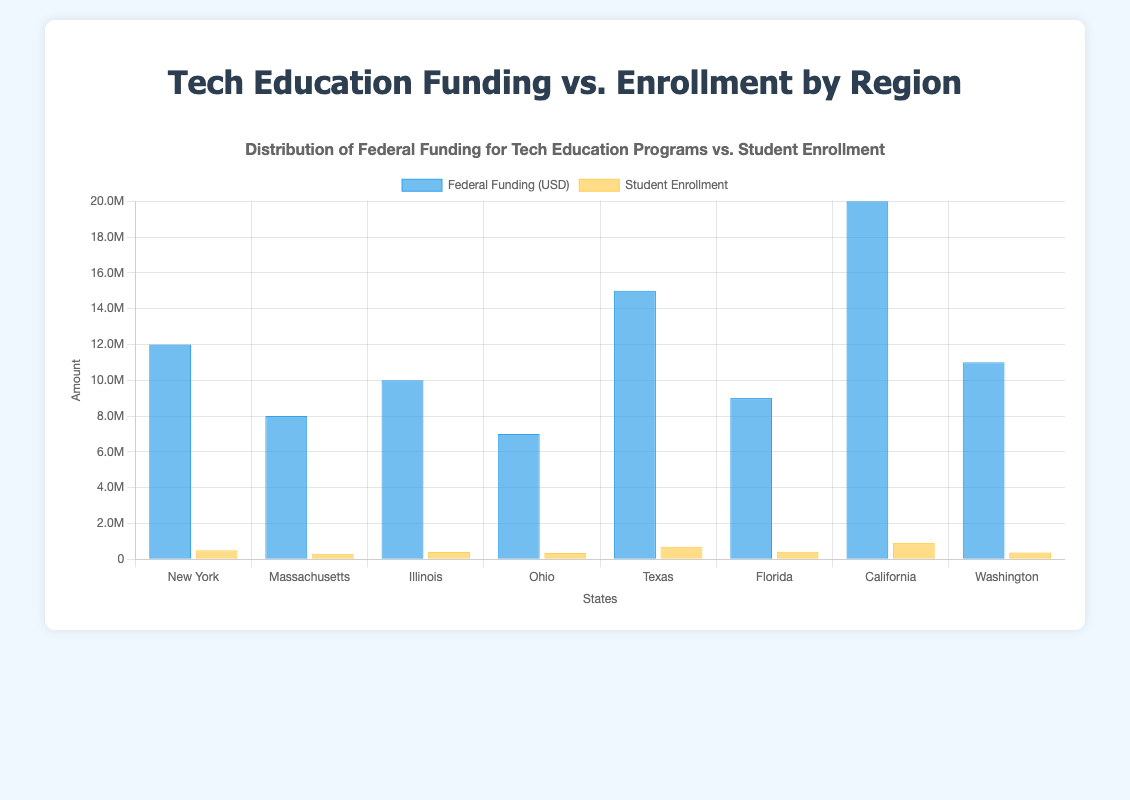Which state in the South region receives the most federal funding for tech education? Texas receives $15,000,000, which is more than Florida's $9,000,000.
Answer: Texas Which state has the highest student enrollment in tech education programs? California has the highest student enrollment with 900,000 students.
Answer: California How does the federal funding for tech education in New York compare to that in Massachusetts? New York receives $12,000,000 while Massachusetts receives $8,000,000. New York gets $4,000,000 more.
Answer: New York receives $4,000,000 more What's the average federal funding for tech education programs in the Northeast region? The Northeast has New York ($12,000,000) and Massachusetts ($8,000,000). Average funding = ($12,000,000 + $8,000,000) / 2 = $10,000,000.
Answer: $10,000,000 Which state has the smallest difference between federal funding and student enrollment numbers? Ohio: $7,000,000 in funding and 350,000 students. Difference = $7,000,000 - 350,000 = $6,650,000
Answer: Ohio In which region does the state with the lowest student enrollment reside? The state with the lowest student enrollment is Massachusetts (300,000) and it is in the Northeast region.
Answer: Northeast What is the total federal funding for tech education in the Midwest region? Adding Illinois ($10,000,000) and Ohio ($7,000,000), the total funding is $17,000,000.
Answer: $17,000,000 What is the percentage of student enrollment in Texas compared to the total student enrollment in all states? Texas has 700,000 students. Total students = 500,000+ 300,000 + 400,000 + 350,000 + 700,000 + 420,000 + 900,000 + 380,000 = 3,950,000. Percentage = (700,000 / 3,950,000) * 100 ≈ 17.72%.
Answer: 17.72% Which state in the West has greater federal funding for tech education and by how much? California ($20,000,000) has more funding than Washington ($11,000,000). The difference is $9,000,000.
Answer: California, $9,000,000 more 